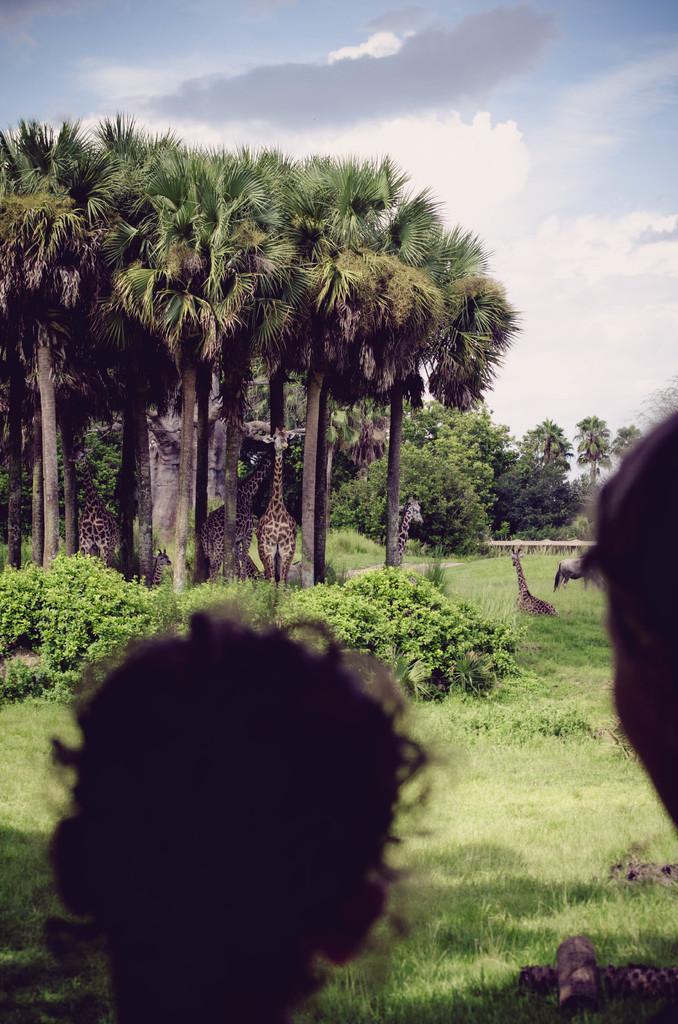How would you summarize this image in a sentence or two? In this picture I can see heads of two persons, there are giraffes, there is grass, there are plants, trees, and in the background there is the sky. 